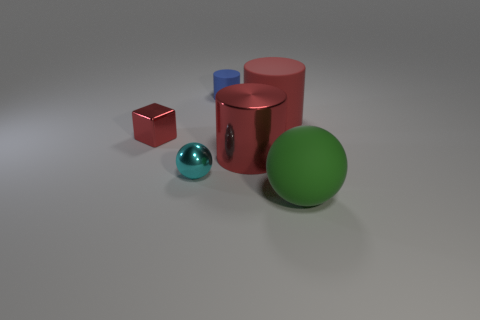Add 4 blue things. How many objects exist? 10 Subtract all cubes. How many objects are left? 5 Add 4 small blue objects. How many small blue objects are left? 5 Add 2 blue objects. How many blue objects exist? 3 Subtract 0 purple cylinders. How many objects are left? 6 Subtract all blue cubes. Subtract all cyan objects. How many objects are left? 5 